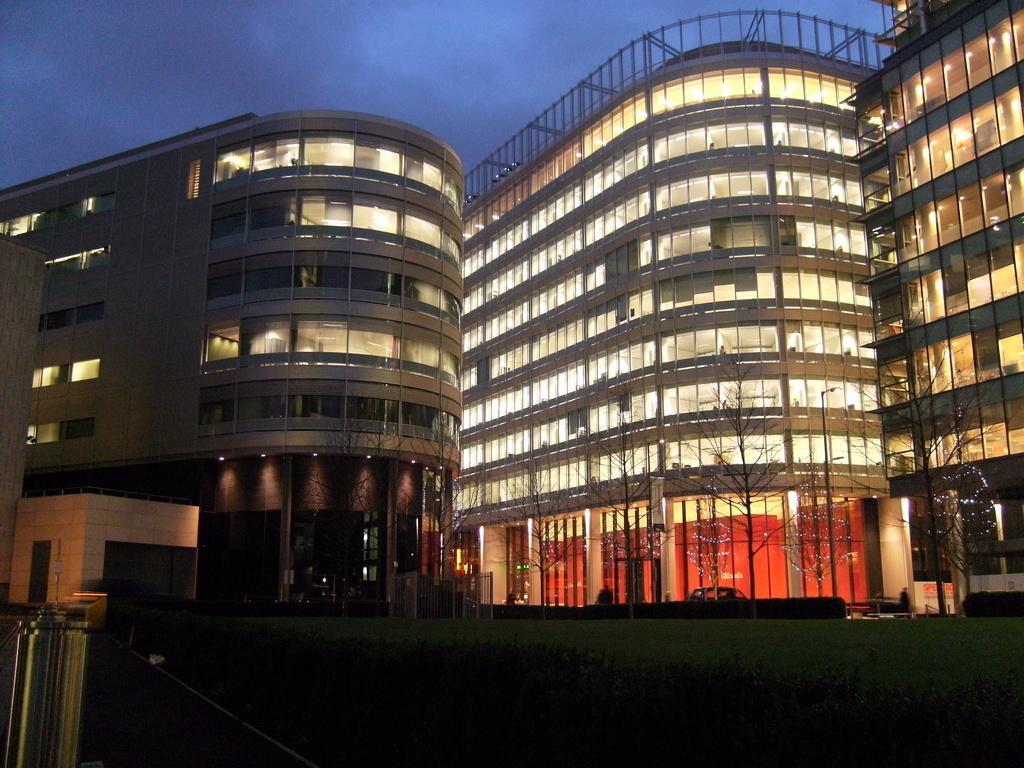Please provide a concise description of this image. In this picture we can see grass, plants, trees, buildings, and lights. In the background there is sky. 